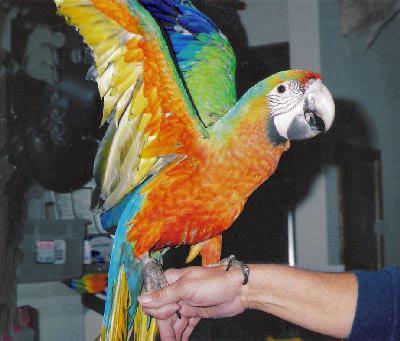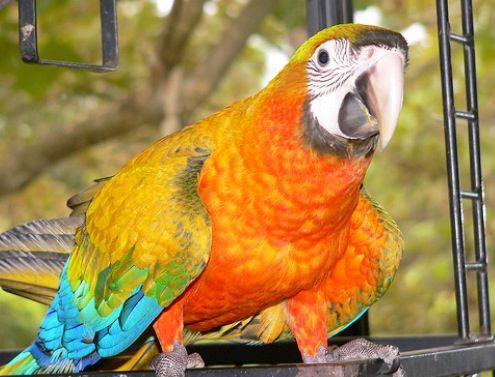The first image is the image on the left, the second image is the image on the right. Considering the images on both sides, is "One image shows a parrot that is nearly all yellow-orange in color, without any blue." valid? Answer yes or no. No. The first image is the image on the left, the second image is the image on the right. Assess this claim about the two images: "Two parrots have the same eye design and beak colors.". Correct or not? Answer yes or no. Yes. 